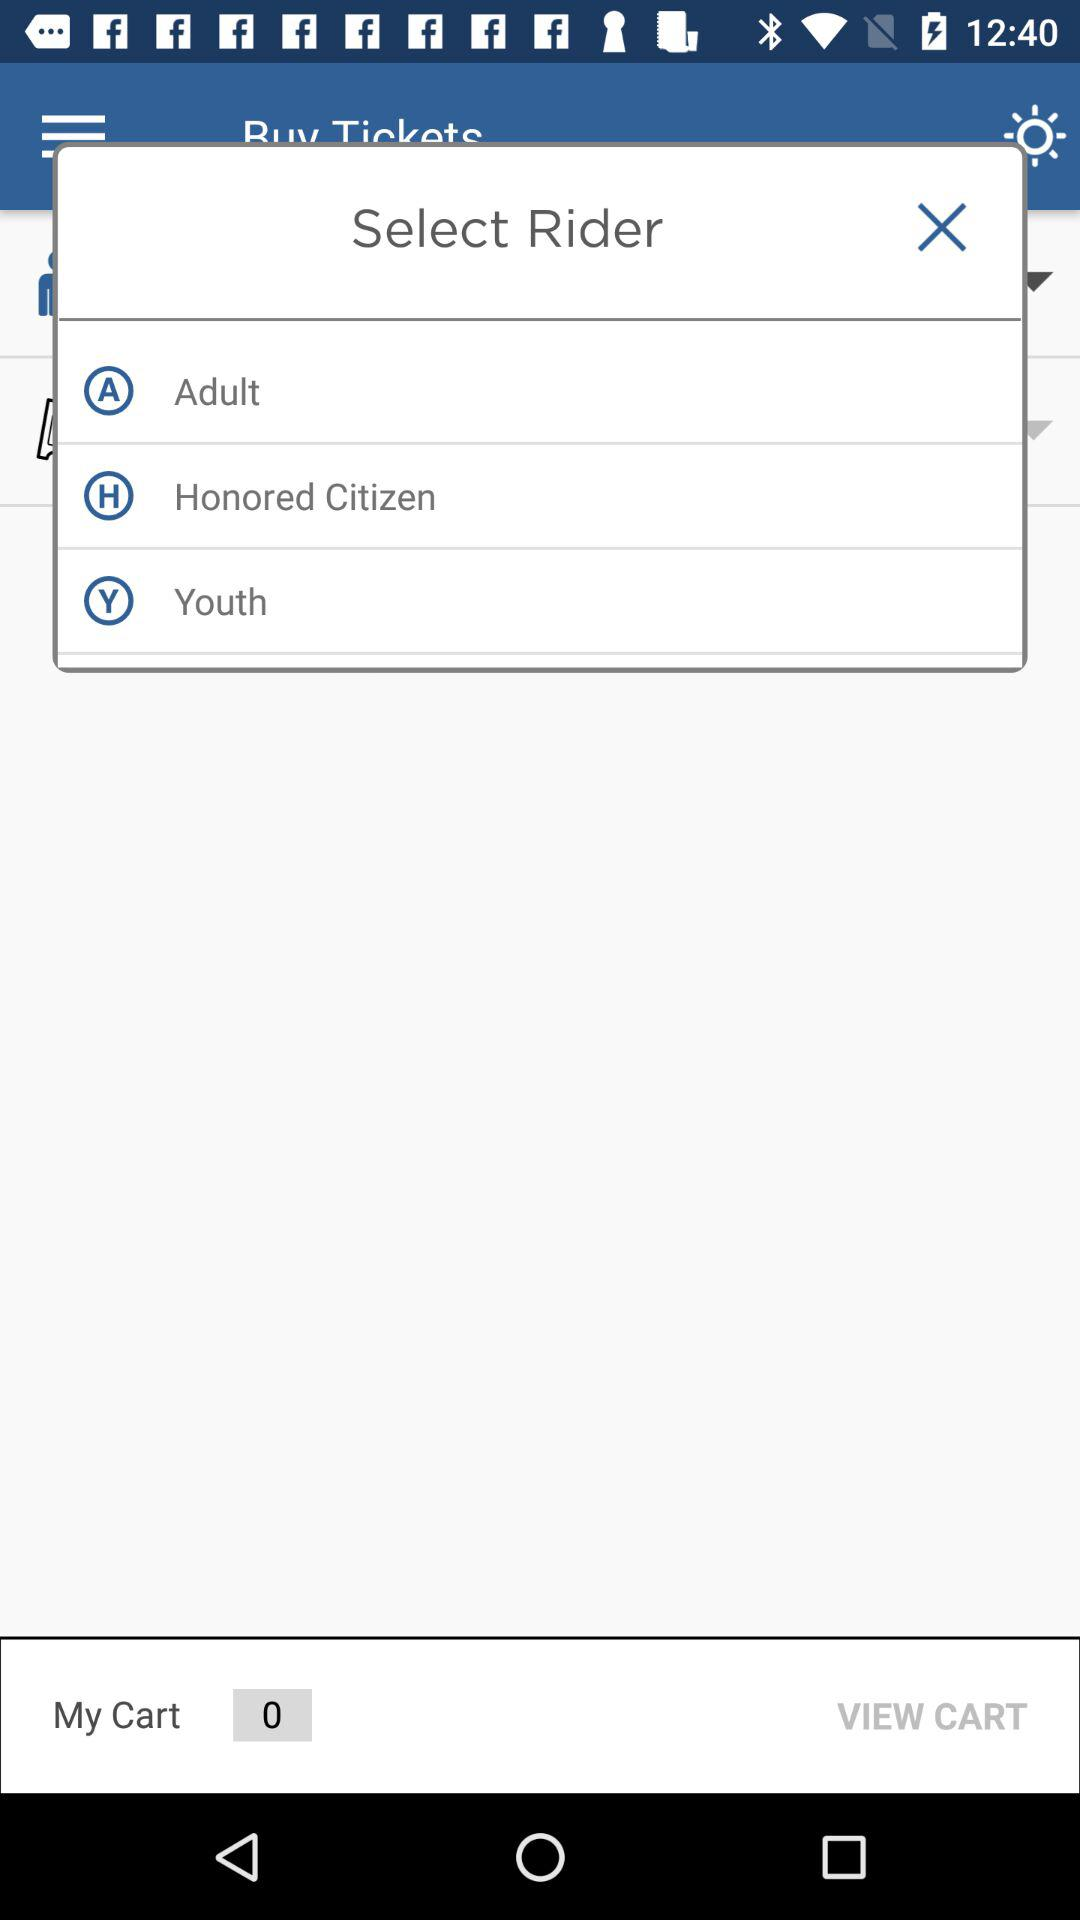What is the value for "My Cart"? The value for "My Cart" is 0. 